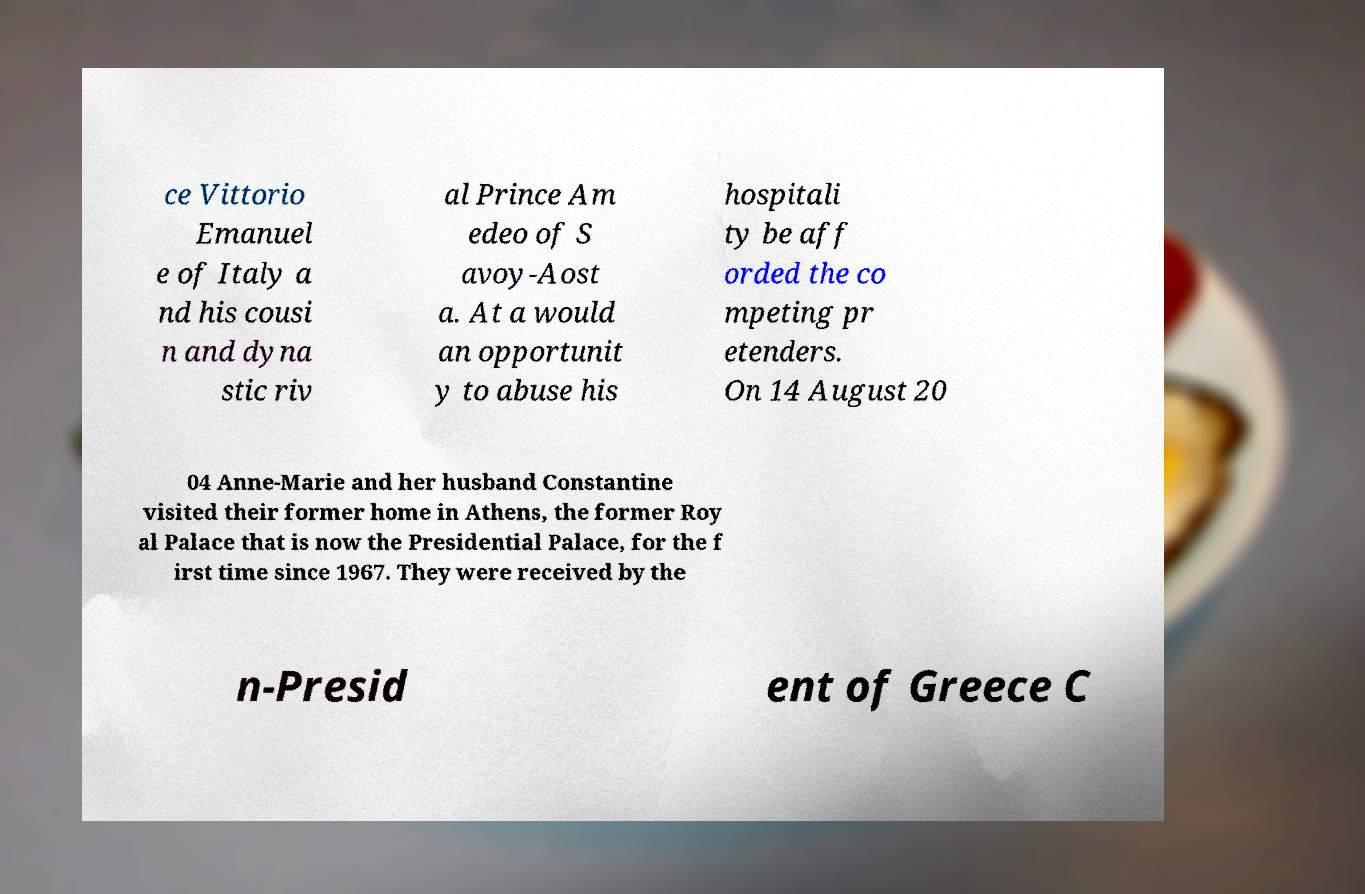For documentation purposes, I need the text within this image transcribed. Could you provide that? ce Vittorio Emanuel e of Italy a nd his cousi n and dyna stic riv al Prince Am edeo of S avoy-Aost a. At a would an opportunit y to abuse his hospitali ty be aff orded the co mpeting pr etenders. On 14 August 20 04 Anne-Marie and her husband Constantine visited their former home in Athens, the former Roy al Palace that is now the Presidential Palace, for the f irst time since 1967. They were received by the n-Presid ent of Greece C 